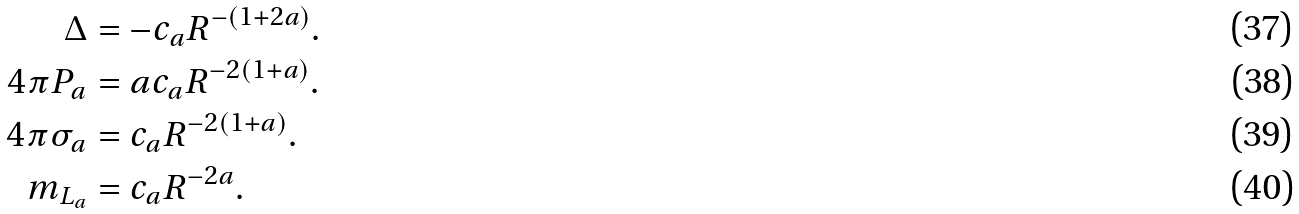Convert formula to latex. <formula><loc_0><loc_0><loc_500><loc_500>\Delta & = - c _ { a } R ^ { - ( 1 + 2 a ) } . \\ 4 \pi P _ { a } & = a c _ { a } R ^ { - 2 ( 1 + a ) } . \\ 4 \pi \sigma _ { a } & = c _ { a } R ^ { - 2 ( 1 + a ) } . \\ m _ { L _ { a } } & = c _ { a } R ^ { - 2 a } .</formula> 